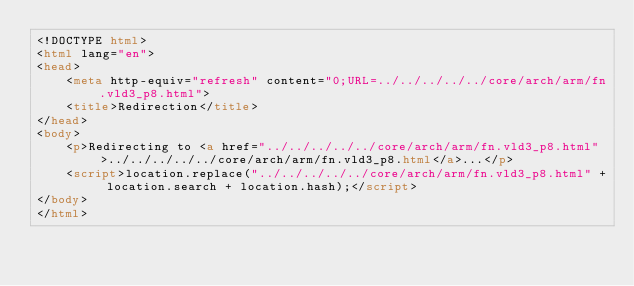<code> <loc_0><loc_0><loc_500><loc_500><_HTML_><!DOCTYPE html>
<html lang="en">
<head>
    <meta http-equiv="refresh" content="0;URL=../../../../../core/arch/arm/fn.vld3_p8.html">
    <title>Redirection</title>
</head>
<body>
    <p>Redirecting to <a href="../../../../../core/arch/arm/fn.vld3_p8.html">../../../../../core/arch/arm/fn.vld3_p8.html</a>...</p>
    <script>location.replace("../../../../../core/arch/arm/fn.vld3_p8.html" + location.search + location.hash);</script>
</body>
</html></code> 